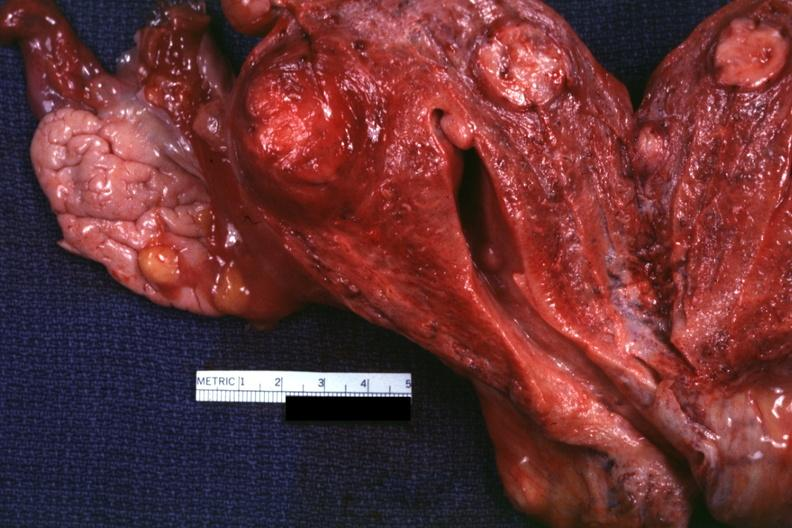does amputation stump infected show cut surface of uterus several lesions?
Answer the question using a single word or phrase. No 